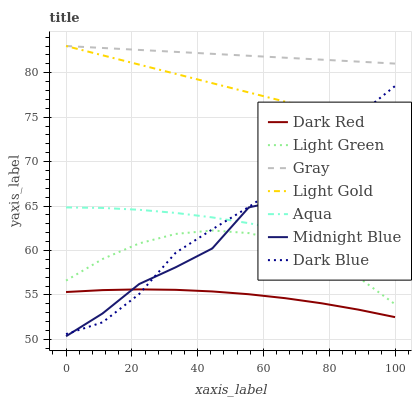Does Dark Red have the minimum area under the curve?
Answer yes or no. Yes. Does Gray have the maximum area under the curve?
Answer yes or no. Yes. Does Midnight Blue have the minimum area under the curve?
Answer yes or no. No. Does Midnight Blue have the maximum area under the curve?
Answer yes or no. No. Is Light Gold the smoothest?
Answer yes or no. Yes. Is Midnight Blue the roughest?
Answer yes or no. Yes. Is Dark Red the smoothest?
Answer yes or no. No. Is Dark Red the roughest?
Answer yes or no. No. Does Midnight Blue have the lowest value?
Answer yes or no. Yes. Does Dark Red have the lowest value?
Answer yes or no. No. Does Light Gold have the highest value?
Answer yes or no. Yes. Does Midnight Blue have the highest value?
Answer yes or no. No. Is Aqua less than Light Gold?
Answer yes or no. Yes. Is Light Gold greater than Aqua?
Answer yes or no. Yes. Does Light Gold intersect Gray?
Answer yes or no. Yes. Is Light Gold less than Gray?
Answer yes or no. No. Is Light Gold greater than Gray?
Answer yes or no. No. Does Aqua intersect Light Gold?
Answer yes or no. No. 